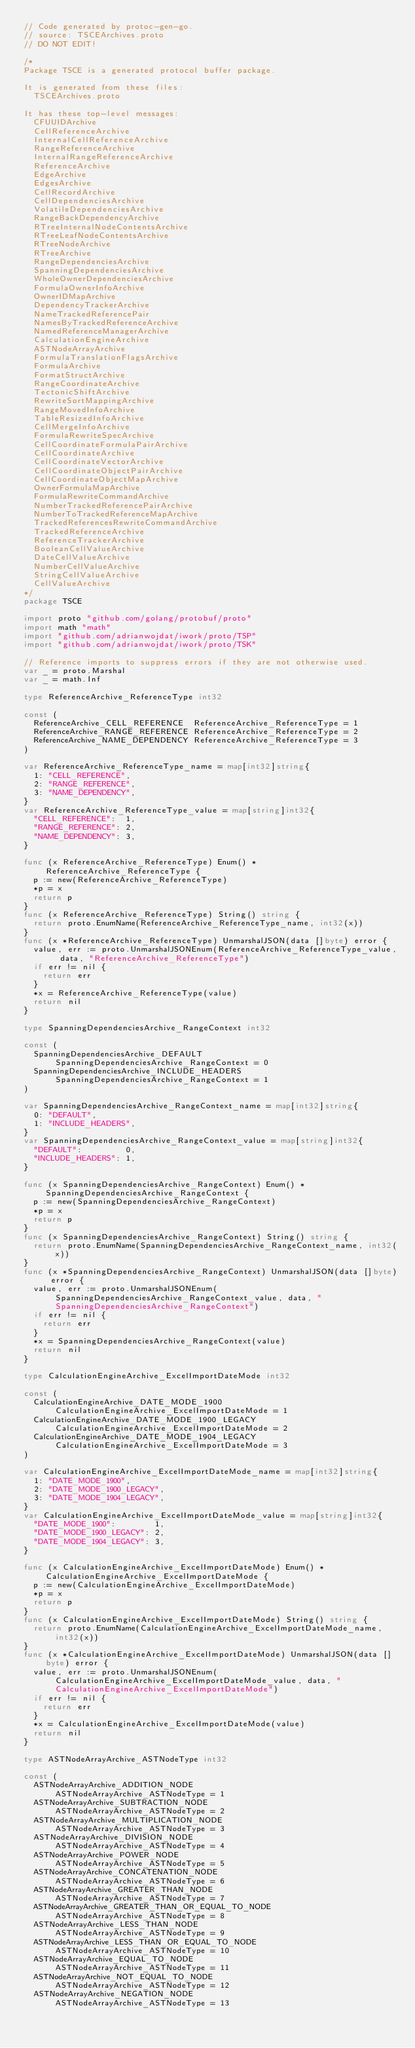<code> <loc_0><loc_0><loc_500><loc_500><_Go_>// Code generated by protoc-gen-go.
// source: TSCEArchives.proto
// DO NOT EDIT!

/*
Package TSCE is a generated protocol buffer package.

It is generated from these files:
	TSCEArchives.proto

It has these top-level messages:
	CFUUIDArchive
	CellReferenceArchive
	InternalCellReferenceArchive
	RangeReferenceArchive
	InternalRangeReferenceArchive
	ReferenceArchive
	EdgeArchive
	EdgesArchive
	CellRecordArchive
	CellDependenciesArchive
	VolatileDependenciesArchive
	RangeBackDependencyArchive
	RTreeInternalNodeContentsArchive
	RTreeLeafNodeContentsArchive
	RTreeNodeArchive
	RTreeArchive
	RangeDependenciesArchive
	SpanningDependenciesArchive
	WholeOwnerDependenciesArchive
	FormulaOwnerInfoArchive
	OwnerIDMapArchive
	DependencyTrackerArchive
	NameTrackedReferencePair
	NamesByTrackedReferenceArchive
	NamedReferenceManagerArchive
	CalculationEngineArchive
	ASTNodeArrayArchive
	FormulaTranslationFlagsArchive
	FormulaArchive
	FormatStructArchive
	RangeCoordinateArchive
	TectonicShiftArchive
	RewriteSortMappingArchive
	RangeMovedInfoArchive
	TableResizedInfoArchive
	CellMergeInfoArchive
	FormulaRewriteSpecArchive
	CellCoordinateFormulaPairArchive
	CellCoordinateArchive
	CellCoordinateVectorArchive
	CellCoordinateObjectPairArchive
	CellCoordinateObjectMapArchive
	OwnerFormulaMapArchive
	FormulaRewriteCommandArchive
	NumberTrackedReferencePairArchive
	NumberToTrackedReferenceMapArchive
	TrackedReferencesRewriteCommandArchive
	TrackedReferenceArchive
	ReferenceTrackerArchive
	BooleanCellValueArchive
	DateCellValueArchive
	NumberCellValueArchive
	StringCellValueArchive
	CellValueArchive
*/
package TSCE

import proto "github.com/golang/protobuf/proto"
import math "math"
import "github.com/adrianwojdat/iwork/proto/TSP"
import "github.com/adrianwojdat/iwork/proto/TSK"

// Reference imports to suppress errors if they are not otherwise used.
var _ = proto.Marshal
var _ = math.Inf

type ReferenceArchive_ReferenceType int32

const (
	ReferenceArchive_CELL_REFERENCE  ReferenceArchive_ReferenceType = 1
	ReferenceArchive_RANGE_REFERENCE ReferenceArchive_ReferenceType = 2
	ReferenceArchive_NAME_DEPENDENCY ReferenceArchive_ReferenceType = 3
)

var ReferenceArchive_ReferenceType_name = map[int32]string{
	1: "CELL_REFERENCE",
	2: "RANGE_REFERENCE",
	3: "NAME_DEPENDENCY",
}
var ReferenceArchive_ReferenceType_value = map[string]int32{
	"CELL_REFERENCE":  1,
	"RANGE_REFERENCE": 2,
	"NAME_DEPENDENCY": 3,
}

func (x ReferenceArchive_ReferenceType) Enum() *ReferenceArchive_ReferenceType {
	p := new(ReferenceArchive_ReferenceType)
	*p = x
	return p
}
func (x ReferenceArchive_ReferenceType) String() string {
	return proto.EnumName(ReferenceArchive_ReferenceType_name, int32(x))
}
func (x *ReferenceArchive_ReferenceType) UnmarshalJSON(data []byte) error {
	value, err := proto.UnmarshalJSONEnum(ReferenceArchive_ReferenceType_value, data, "ReferenceArchive_ReferenceType")
	if err != nil {
		return err
	}
	*x = ReferenceArchive_ReferenceType(value)
	return nil
}

type SpanningDependenciesArchive_RangeContext int32

const (
	SpanningDependenciesArchive_DEFAULT         SpanningDependenciesArchive_RangeContext = 0
	SpanningDependenciesArchive_INCLUDE_HEADERS SpanningDependenciesArchive_RangeContext = 1
)

var SpanningDependenciesArchive_RangeContext_name = map[int32]string{
	0: "DEFAULT",
	1: "INCLUDE_HEADERS",
}
var SpanningDependenciesArchive_RangeContext_value = map[string]int32{
	"DEFAULT":         0,
	"INCLUDE_HEADERS": 1,
}

func (x SpanningDependenciesArchive_RangeContext) Enum() *SpanningDependenciesArchive_RangeContext {
	p := new(SpanningDependenciesArchive_RangeContext)
	*p = x
	return p
}
func (x SpanningDependenciesArchive_RangeContext) String() string {
	return proto.EnumName(SpanningDependenciesArchive_RangeContext_name, int32(x))
}
func (x *SpanningDependenciesArchive_RangeContext) UnmarshalJSON(data []byte) error {
	value, err := proto.UnmarshalJSONEnum(SpanningDependenciesArchive_RangeContext_value, data, "SpanningDependenciesArchive_RangeContext")
	if err != nil {
		return err
	}
	*x = SpanningDependenciesArchive_RangeContext(value)
	return nil
}

type CalculationEngineArchive_ExcelImportDateMode int32

const (
	CalculationEngineArchive_DATE_MODE_1900        CalculationEngineArchive_ExcelImportDateMode = 1
	CalculationEngineArchive_DATE_MODE_1900_LEGACY CalculationEngineArchive_ExcelImportDateMode = 2
	CalculationEngineArchive_DATE_MODE_1904_LEGACY CalculationEngineArchive_ExcelImportDateMode = 3
)

var CalculationEngineArchive_ExcelImportDateMode_name = map[int32]string{
	1: "DATE_MODE_1900",
	2: "DATE_MODE_1900_LEGACY",
	3: "DATE_MODE_1904_LEGACY",
}
var CalculationEngineArchive_ExcelImportDateMode_value = map[string]int32{
	"DATE_MODE_1900":        1,
	"DATE_MODE_1900_LEGACY": 2,
	"DATE_MODE_1904_LEGACY": 3,
}

func (x CalculationEngineArchive_ExcelImportDateMode) Enum() *CalculationEngineArchive_ExcelImportDateMode {
	p := new(CalculationEngineArchive_ExcelImportDateMode)
	*p = x
	return p
}
func (x CalculationEngineArchive_ExcelImportDateMode) String() string {
	return proto.EnumName(CalculationEngineArchive_ExcelImportDateMode_name, int32(x))
}
func (x *CalculationEngineArchive_ExcelImportDateMode) UnmarshalJSON(data []byte) error {
	value, err := proto.UnmarshalJSONEnum(CalculationEngineArchive_ExcelImportDateMode_value, data, "CalculationEngineArchive_ExcelImportDateMode")
	if err != nil {
		return err
	}
	*x = CalculationEngineArchive_ExcelImportDateMode(value)
	return nil
}

type ASTNodeArrayArchive_ASTNodeType int32

const (
	ASTNodeArrayArchive_ADDITION_NODE                   ASTNodeArrayArchive_ASTNodeType = 1
	ASTNodeArrayArchive_SUBTRACTION_NODE                ASTNodeArrayArchive_ASTNodeType = 2
	ASTNodeArrayArchive_MULTIPLICATION_NODE             ASTNodeArrayArchive_ASTNodeType = 3
	ASTNodeArrayArchive_DIVISION_NODE                   ASTNodeArrayArchive_ASTNodeType = 4
	ASTNodeArrayArchive_POWER_NODE                      ASTNodeArrayArchive_ASTNodeType = 5
	ASTNodeArrayArchive_CONCATENATION_NODE              ASTNodeArrayArchive_ASTNodeType = 6
	ASTNodeArrayArchive_GREATER_THAN_NODE               ASTNodeArrayArchive_ASTNodeType = 7
	ASTNodeArrayArchive_GREATER_THAN_OR_EQUAL_TO_NODE   ASTNodeArrayArchive_ASTNodeType = 8
	ASTNodeArrayArchive_LESS_THAN_NODE                  ASTNodeArrayArchive_ASTNodeType = 9
	ASTNodeArrayArchive_LESS_THAN_OR_EQUAL_TO_NODE      ASTNodeArrayArchive_ASTNodeType = 10
	ASTNodeArrayArchive_EQUAL_TO_NODE                   ASTNodeArrayArchive_ASTNodeType = 11
	ASTNodeArrayArchive_NOT_EQUAL_TO_NODE               ASTNodeArrayArchive_ASTNodeType = 12
	ASTNodeArrayArchive_NEGATION_NODE                   ASTNodeArrayArchive_ASTNodeType = 13</code> 